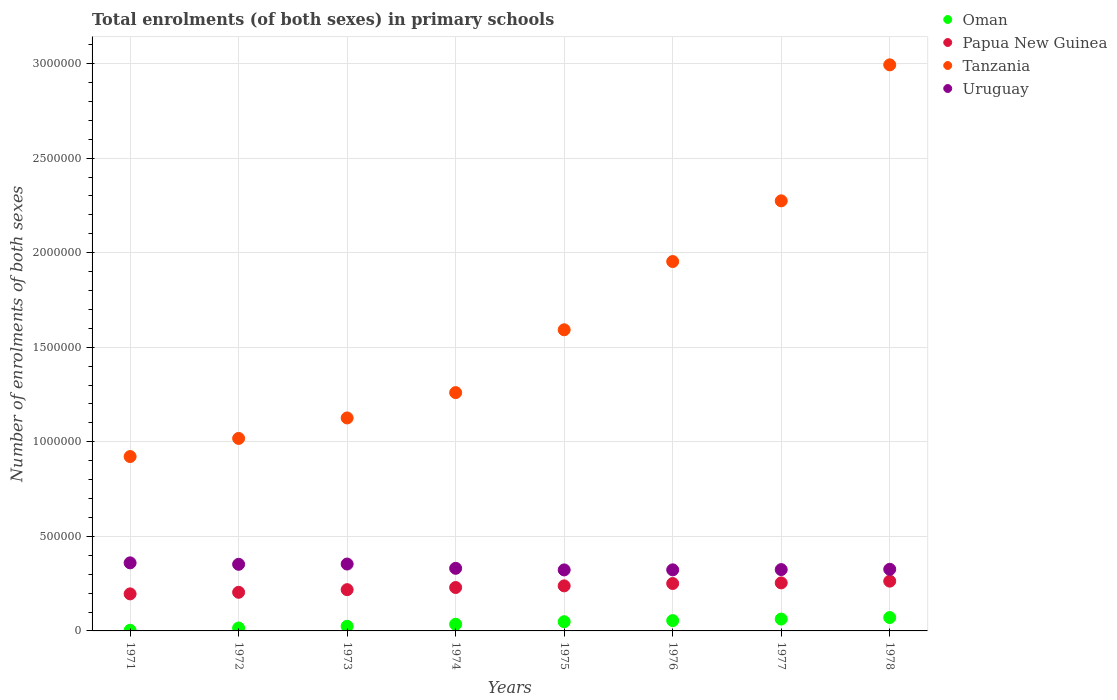Is the number of dotlines equal to the number of legend labels?
Provide a succinct answer. Yes. What is the number of enrolments in primary schools in Papua New Guinea in 1977?
Provide a succinct answer. 2.54e+05. Across all years, what is the maximum number of enrolments in primary schools in Tanzania?
Give a very brief answer. 2.99e+06. Across all years, what is the minimum number of enrolments in primary schools in Papua New Guinea?
Your answer should be very brief. 1.96e+05. In which year was the number of enrolments in primary schools in Uruguay maximum?
Make the answer very short. 1971. What is the total number of enrolments in primary schools in Uruguay in the graph?
Your response must be concise. 2.69e+06. What is the difference between the number of enrolments in primary schools in Tanzania in 1973 and that in 1974?
Provide a short and direct response. -1.34e+05. What is the difference between the number of enrolments in primary schools in Uruguay in 1978 and the number of enrolments in primary schools in Papua New Guinea in 1974?
Provide a short and direct response. 9.64e+04. What is the average number of enrolments in primary schools in Uruguay per year?
Offer a terse response. 3.37e+05. In the year 1977, what is the difference between the number of enrolments in primary schools in Oman and number of enrolments in primary schools in Uruguay?
Offer a very short reply. -2.62e+05. In how many years, is the number of enrolments in primary schools in Uruguay greater than 900000?
Give a very brief answer. 0. What is the ratio of the number of enrolments in primary schools in Papua New Guinea in 1971 to that in 1976?
Provide a short and direct response. 0.78. Is the number of enrolments in primary schools in Tanzania in 1972 less than that in 1974?
Make the answer very short. Yes. Is the difference between the number of enrolments in primary schools in Oman in 1976 and 1978 greater than the difference between the number of enrolments in primary schools in Uruguay in 1976 and 1978?
Offer a very short reply. No. What is the difference between the highest and the second highest number of enrolments in primary schools in Uruguay?
Provide a short and direct response. 6275. What is the difference between the highest and the lowest number of enrolments in primary schools in Oman?
Keep it short and to the point. 6.73e+04. Is the sum of the number of enrolments in primary schools in Uruguay in 1976 and 1978 greater than the maximum number of enrolments in primary schools in Oman across all years?
Your answer should be compact. Yes. Is it the case that in every year, the sum of the number of enrolments in primary schools in Uruguay and number of enrolments in primary schools in Papua New Guinea  is greater than the sum of number of enrolments in primary schools in Oman and number of enrolments in primary schools in Tanzania?
Offer a terse response. No. Is it the case that in every year, the sum of the number of enrolments in primary schools in Tanzania and number of enrolments in primary schools in Papua New Guinea  is greater than the number of enrolments in primary schools in Uruguay?
Give a very brief answer. Yes. Does the number of enrolments in primary schools in Papua New Guinea monotonically increase over the years?
Your response must be concise. Yes. Is the number of enrolments in primary schools in Uruguay strictly less than the number of enrolments in primary schools in Oman over the years?
Give a very brief answer. No. How many dotlines are there?
Ensure brevity in your answer.  4. Does the graph contain grids?
Give a very brief answer. Yes. Where does the legend appear in the graph?
Your answer should be compact. Top right. How many legend labels are there?
Ensure brevity in your answer.  4. How are the legend labels stacked?
Your answer should be compact. Vertical. What is the title of the graph?
Keep it short and to the point. Total enrolments (of both sexes) in primary schools. Does "Bhutan" appear as one of the legend labels in the graph?
Provide a succinct answer. No. What is the label or title of the X-axis?
Give a very brief answer. Years. What is the label or title of the Y-axis?
Your response must be concise. Number of enrolments of both sexes. What is the Number of enrolments of both sexes of Oman in 1971?
Keep it short and to the point. 3478. What is the Number of enrolments of both sexes of Papua New Guinea in 1971?
Offer a very short reply. 1.96e+05. What is the Number of enrolments of both sexes of Tanzania in 1971?
Your response must be concise. 9.22e+05. What is the Number of enrolments of both sexes of Uruguay in 1971?
Your answer should be compact. 3.60e+05. What is the Number of enrolments of both sexes in Oman in 1972?
Make the answer very short. 1.53e+04. What is the Number of enrolments of both sexes of Papua New Guinea in 1972?
Give a very brief answer. 2.04e+05. What is the Number of enrolments of both sexes of Tanzania in 1972?
Your response must be concise. 1.02e+06. What is the Number of enrolments of both sexes in Uruguay in 1972?
Ensure brevity in your answer.  3.52e+05. What is the Number of enrolments of both sexes of Oman in 1973?
Offer a terse response. 2.44e+04. What is the Number of enrolments of both sexes of Papua New Guinea in 1973?
Your answer should be very brief. 2.18e+05. What is the Number of enrolments of both sexes in Tanzania in 1973?
Your response must be concise. 1.13e+06. What is the Number of enrolments of both sexes in Uruguay in 1973?
Offer a terse response. 3.54e+05. What is the Number of enrolments of both sexes of Oman in 1974?
Offer a terse response. 3.53e+04. What is the Number of enrolments of both sexes of Papua New Guinea in 1974?
Your answer should be very brief. 2.30e+05. What is the Number of enrolments of both sexes in Tanzania in 1974?
Provide a succinct answer. 1.26e+06. What is the Number of enrolments of both sexes of Uruguay in 1974?
Your answer should be compact. 3.31e+05. What is the Number of enrolments of both sexes in Oman in 1975?
Ensure brevity in your answer.  4.86e+04. What is the Number of enrolments of both sexes in Papua New Guinea in 1975?
Provide a short and direct response. 2.38e+05. What is the Number of enrolments of both sexes in Tanzania in 1975?
Provide a short and direct response. 1.59e+06. What is the Number of enrolments of both sexes in Uruguay in 1975?
Provide a short and direct response. 3.23e+05. What is the Number of enrolments of both sexes of Oman in 1976?
Offer a very short reply. 5.46e+04. What is the Number of enrolments of both sexes of Papua New Guinea in 1976?
Your answer should be compact. 2.51e+05. What is the Number of enrolments of both sexes of Tanzania in 1976?
Your answer should be very brief. 1.95e+06. What is the Number of enrolments of both sexes of Uruguay in 1976?
Make the answer very short. 3.23e+05. What is the Number of enrolments of both sexes in Oman in 1977?
Keep it short and to the point. 6.26e+04. What is the Number of enrolments of both sexes in Papua New Guinea in 1977?
Your answer should be compact. 2.54e+05. What is the Number of enrolments of both sexes in Tanzania in 1977?
Ensure brevity in your answer.  2.27e+06. What is the Number of enrolments of both sexes in Uruguay in 1977?
Your response must be concise. 3.24e+05. What is the Number of enrolments of both sexes of Oman in 1978?
Ensure brevity in your answer.  7.08e+04. What is the Number of enrolments of both sexes in Papua New Guinea in 1978?
Offer a very short reply. 2.63e+05. What is the Number of enrolments of both sexes in Tanzania in 1978?
Provide a short and direct response. 2.99e+06. What is the Number of enrolments of both sexes of Uruguay in 1978?
Provide a succinct answer. 3.26e+05. Across all years, what is the maximum Number of enrolments of both sexes in Oman?
Keep it short and to the point. 7.08e+04. Across all years, what is the maximum Number of enrolments of both sexes of Papua New Guinea?
Your response must be concise. 2.63e+05. Across all years, what is the maximum Number of enrolments of both sexes of Tanzania?
Offer a terse response. 2.99e+06. Across all years, what is the maximum Number of enrolments of both sexes of Uruguay?
Keep it short and to the point. 3.60e+05. Across all years, what is the minimum Number of enrolments of both sexes in Oman?
Give a very brief answer. 3478. Across all years, what is the minimum Number of enrolments of both sexes in Papua New Guinea?
Provide a succinct answer. 1.96e+05. Across all years, what is the minimum Number of enrolments of both sexes in Tanzania?
Ensure brevity in your answer.  9.22e+05. Across all years, what is the minimum Number of enrolments of both sexes in Uruguay?
Keep it short and to the point. 3.23e+05. What is the total Number of enrolments of both sexes of Oman in the graph?
Provide a succinct answer. 3.15e+05. What is the total Number of enrolments of both sexes of Papua New Guinea in the graph?
Your answer should be compact. 1.85e+06. What is the total Number of enrolments of both sexes of Tanzania in the graph?
Your response must be concise. 1.31e+07. What is the total Number of enrolments of both sexes of Uruguay in the graph?
Offer a terse response. 2.69e+06. What is the difference between the Number of enrolments of both sexes in Oman in 1971 and that in 1972?
Offer a terse response. -1.19e+04. What is the difference between the Number of enrolments of both sexes in Papua New Guinea in 1971 and that in 1972?
Provide a succinct answer. -8359. What is the difference between the Number of enrolments of both sexes in Tanzania in 1971 and that in 1972?
Your response must be concise. -9.59e+04. What is the difference between the Number of enrolments of both sexes in Uruguay in 1971 and that in 1972?
Offer a terse response. 7719. What is the difference between the Number of enrolments of both sexes of Oman in 1971 and that in 1973?
Offer a terse response. -2.09e+04. What is the difference between the Number of enrolments of both sexes of Papua New Guinea in 1971 and that in 1973?
Offer a terse response. -2.23e+04. What is the difference between the Number of enrolments of both sexes in Tanzania in 1971 and that in 1973?
Your response must be concise. -2.04e+05. What is the difference between the Number of enrolments of both sexes in Uruguay in 1971 and that in 1973?
Your response must be concise. 6275. What is the difference between the Number of enrolments of both sexes in Oman in 1971 and that in 1974?
Your answer should be very brief. -3.18e+04. What is the difference between the Number of enrolments of both sexes of Papua New Guinea in 1971 and that in 1974?
Ensure brevity in your answer.  -3.37e+04. What is the difference between the Number of enrolments of both sexes of Tanzania in 1971 and that in 1974?
Your answer should be compact. -3.38e+05. What is the difference between the Number of enrolments of both sexes in Uruguay in 1971 and that in 1974?
Your answer should be very brief. 2.89e+04. What is the difference between the Number of enrolments of both sexes in Oman in 1971 and that in 1975?
Offer a terse response. -4.52e+04. What is the difference between the Number of enrolments of both sexes in Papua New Guinea in 1971 and that in 1975?
Your answer should be very brief. -4.24e+04. What is the difference between the Number of enrolments of both sexes in Tanzania in 1971 and that in 1975?
Provide a short and direct response. -6.70e+05. What is the difference between the Number of enrolments of both sexes of Uruguay in 1971 and that in 1975?
Provide a short and direct response. 3.73e+04. What is the difference between the Number of enrolments of both sexes in Oman in 1971 and that in 1976?
Your answer should be very brief. -5.11e+04. What is the difference between the Number of enrolments of both sexes of Papua New Guinea in 1971 and that in 1976?
Ensure brevity in your answer.  -5.49e+04. What is the difference between the Number of enrolments of both sexes in Tanzania in 1971 and that in 1976?
Provide a short and direct response. -1.03e+06. What is the difference between the Number of enrolments of both sexes in Uruguay in 1971 and that in 1976?
Offer a very short reply. 3.70e+04. What is the difference between the Number of enrolments of both sexes of Oman in 1971 and that in 1977?
Offer a very short reply. -5.92e+04. What is the difference between the Number of enrolments of both sexes in Papua New Guinea in 1971 and that in 1977?
Give a very brief answer. -5.81e+04. What is the difference between the Number of enrolments of both sexes of Tanzania in 1971 and that in 1977?
Ensure brevity in your answer.  -1.35e+06. What is the difference between the Number of enrolments of both sexes of Uruguay in 1971 and that in 1977?
Your response must be concise. 3.56e+04. What is the difference between the Number of enrolments of both sexes of Oman in 1971 and that in 1978?
Give a very brief answer. -6.73e+04. What is the difference between the Number of enrolments of both sexes of Papua New Guinea in 1971 and that in 1978?
Provide a succinct answer. -6.73e+04. What is the difference between the Number of enrolments of both sexes of Tanzania in 1971 and that in 1978?
Ensure brevity in your answer.  -2.07e+06. What is the difference between the Number of enrolments of both sexes in Uruguay in 1971 and that in 1978?
Provide a succinct answer. 3.40e+04. What is the difference between the Number of enrolments of both sexes in Oman in 1972 and that in 1973?
Your answer should be compact. -9079. What is the difference between the Number of enrolments of both sexes of Papua New Guinea in 1972 and that in 1973?
Provide a succinct answer. -1.39e+04. What is the difference between the Number of enrolments of both sexes in Tanzania in 1972 and that in 1973?
Ensure brevity in your answer.  -1.08e+05. What is the difference between the Number of enrolments of both sexes of Uruguay in 1972 and that in 1973?
Provide a succinct answer. -1444. What is the difference between the Number of enrolments of both sexes of Oman in 1972 and that in 1974?
Offer a terse response. -2.00e+04. What is the difference between the Number of enrolments of both sexes in Papua New Guinea in 1972 and that in 1974?
Offer a very short reply. -2.53e+04. What is the difference between the Number of enrolments of both sexes in Tanzania in 1972 and that in 1974?
Ensure brevity in your answer.  -2.42e+05. What is the difference between the Number of enrolments of both sexes of Uruguay in 1972 and that in 1974?
Provide a succinct answer. 2.12e+04. What is the difference between the Number of enrolments of both sexes in Oman in 1972 and that in 1975?
Ensure brevity in your answer.  -3.33e+04. What is the difference between the Number of enrolments of both sexes of Papua New Guinea in 1972 and that in 1975?
Make the answer very short. -3.40e+04. What is the difference between the Number of enrolments of both sexes of Tanzania in 1972 and that in 1975?
Ensure brevity in your answer.  -5.74e+05. What is the difference between the Number of enrolments of both sexes of Uruguay in 1972 and that in 1975?
Keep it short and to the point. 2.96e+04. What is the difference between the Number of enrolments of both sexes of Oman in 1972 and that in 1976?
Your response must be concise. -3.93e+04. What is the difference between the Number of enrolments of both sexes in Papua New Guinea in 1972 and that in 1976?
Give a very brief answer. -4.65e+04. What is the difference between the Number of enrolments of both sexes of Tanzania in 1972 and that in 1976?
Give a very brief answer. -9.35e+05. What is the difference between the Number of enrolments of both sexes of Uruguay in 1972 and that in 1976?
Your answer should be compact. 2.93e+04. What is the difference between the Number of enrolments of both sexes in Oman in 1972 and that in 1977?
Ensure brevity in your answer.  -4.73e+04. What is the difference between the Number of enrolments of both sexes of Papua New Guinea in 1972 and that in 1977?
Keep it short and to the point. -4.98e+04. What is the difference between the Number of enrolments of both sexes of Tanzania in 1972 and that in 1977?
Keep it short and to the point. -1.26e+06. What is the difference between the Number of enrolments of both sexes in Uruguay in 1972 and that in 1977?
Provide a succinct answer. 2.78e+04. What is the difference between the Number of enrolments of both sexes of Oman in 1972 and that in 1978?
Your response must be concise. -5.54e+04. What is the difference between the Number of enrolments of both sexes in Papua New Guinea in 1972 and that in 1978?
Make the answer very short. -5.90e+04. What is the difference between the Number of enrolments of both sexes in Tanzania in 1972 and that in 1978?
Keep it short and to the point. -1.98e+06. What is the difference between the Number of enrolments of both sexes of Uruguay in 1972 and that in 1978?
Ensure brevity in your answer.  2.63e+04. What is the difference between the Number of enrolments of both sexes of Oman in 1973 and that in 1974?
Make the answer very short. -1.09e+04. What is the difference between the Number of enrolments of both sexes in Papua New Guinea in 1973 and that in 1974?
Provide a short and direct response. -1.14e+04. What is the difference between the Number of enrolments of both sexes in Tanzania in 1973 and that in 1974?
Provide a short and direct response. -1.34e+05. What is the difference between the Number of enrolments of both sexes of Uruguay in 1973 and that in 1974?
Provide a succinct answer. 2.26e+04. What is the difference between the Number of enrolments of both sexes of Oman in 1973 and that in 1975?
Provide a succinct answer. -2.42e+04. What is the difference between the Number of enrolments of both sexes in Papua New Guinea in 1973 and that in 1975?
Your answer should be very brief. -2.01e+04. What is the difference between the Number of enrolments of both sexes of Tanzania in 1973 and that in 1975?
Keep it short and to the point. -4.66e+05. What is the difference between the Number of enrolments of both sexes of Uruguay in 1973 and that in 1975?
Offer a very short reply. 3.11e+04. What is the difference between the Number of enrolments of both sexes in Oman in 1973 and that in 1976?
Ensure brevity in your answer.  -3.02e+04. What is the difference between the Number of enrolments of both sexes in Papua New Guinea in 1973 and that in 1976?
Ensure brevity in your answer.  -3.25e+04. What is the difference between the Number of enrolments of both sexes in Tanzania in 1973 and that in 1976?
Your response must be concise. -8.27e+05. What is the difference between the Number of enrolments of both sexes in Uruguay in 1973 and that in 1976?
Keep it short and to the point. 3.07e+04. What is the difference between the Number of enrolments of both sexes in Oman in 1973 and that in 1977?
Make the answer very short. -3.82e+04. What is the difference between the Number of enrolments of both sexes in Papua New Guinea in 1973 and that in 1977?
Provide a succinct answer. -3.58e+04. What is the difference between the Number of enrolments of both sexes in Tanzania in 1973 and that in 1977?
Give a very brief answer. -1.15e+06. What is the difference between the Number of enrolments of both sexes of Uruguay in 1973 and that in 1977?
Ensure brevity in your answer.  2.93e+04. What is the difference between the Number of enrolments of both sexes of Oman in 1973 and that in 1978?
Provide a short and direct response. -4.63e+04. What is the difference between the Number of enrolments of both sexes of Papua New Guinea in 1973 and that in 1978?
Offer a very short reply. -4.50e+04. What is the difference between the Number of enrolments of both sexes of Tanzania in 1973 and that in 1978?
Offer a terse response. -1.87e+06. What is the difference between the Number of enrolments of both sexes in Uruguay in 1973 and that in 1978?
Give a very brief answer. 2.78e+04. What is the difference between the Number of enrolments of both sexes of Oman in 1974 and that in 1975?
Your answer should be compact. -1.34e+04. What is the difference between the Number of enrolments of both sexes of Papua New Guinea in 1974 and that in 1975?
Your answer should be very brief. -8740. What is the difference between the Number of enrolments of both sexes in Tanzania in 1974 and that in 1975?
Give a very brief answer. -3.32e+05. What is the difference between the Number of enrolments of both sexes in Uruguay in 1974 and that in 1975?
Your response must be concise. 8445. What is the difference between the Number of enrolments of both sexes of Oman in 1974 and that in 1976?
Provide a short and direct response. -1.93e+04. What is the difference between the Number of enrolments of both sexes in Papua New Guinea in 1974 and that in 1976?
Make the answer very short. -2.12e+04. What is the difference between the Number of enrolments of both sexes of Tanzania in 1974 and that in 1976?
Keep it short and to the point. -6.93e+05. What is the difference between the Number of enrolments of both sexes in Uruguay in 1974 and that in 1976?
Ensure brevity in your answer.  8105. What is the difference between the Number of enrolments of both sexes in Oman in 1974 and that in 1977?
Your response must be concise. -2.73e+04. What is the difference between the Number of enrolments of both sexes in Papua New Guinea in 1974 and that in 1977?
Offer a very short reply. -2.45e+04. What is the difference between the Number of enrolments of both sexes of Tanzania in 1974 and that in 1977?
Your answer should be very brief. -1.01e+06. What is the difference between the Number of enrolments of both sexes of Uruguay in 1974 and that in 1977?
Ensure brevity in your answer.  6686. What is the difference between the Number of enrolments of both sexes in Oman in 1974 and that in 1978?
Provide a succinct answer. -3.55e+04. What is the difference between the Number of enrolments of both sexes of Papua New Guinea in 1974 and that in 1978?
Your answer should be very brief. -3.36e+04. What is the difference between the Number of enrolments of both sexes in Tanzania in 1974 and that in 1978?
Provide a succinct answer. -1.73e+06. What is the difference between the Number of enrolments of both sexes in Uruguay in 1974 and that in 1978?
Ensure brevity in your answer.  5159. What is the difference between the Number of enrolments of both sexes in Oman in 1975 and that in 1976?
Give a very brief answer. -5962. What is the difference between the Number of enrolments of both sexes in Papua New Guinea in 1975 and that in 1976?
Make the answer very short. -1.24e+04. What is the difference between the Number of enrolments of both sexes of Tanzania in 1975 and that in 1976?
Your response must be concise. -3.61e+05. What is the difference between the Number of enrolments of both sexes of Uruguay in 1975 and that in 1976?
Ensure brevity in your answer.  -340. What is the difference between the Number of enrolments of both sexes of Oman in 1975 and that in 1977?
Your response must be concise. -1.40e+04. What is the difference between the Number of enrolments of both sexes of Papua New Guinea in 1975 and that in 1977?
Your answer should be compact. -1.57e+04. What is the difference between the Number of enrolments of both sexes of Tanzania in 1975 and that in 1977?
Keep it short and to the point. -6.82e+05. What is the difference between the Number of enrolments of both sexes of Uruguay in 1975 and that in 1977?
Keep it short and to the point. -1759. What is the difference between the Number of enrolments of both sexes in Oman in 1975 and that in 1978?
Provide a succinct answer. -2.21e+04. What is the difference between the Number of enrolments of both sexes of Papua New Guinea in 1975 and that in 1978?
Offer a terse response. -2.49e+04. What is the difference between the Number of enrolments of both sexes in Tanzania in 1975 and that in 1978?
Your answer should be very brief. -1.40e+06. What is the difference between the Number of enrolments of both sexes of Uruguay in 1975 and that in 1978?
Your answer should be compact. -3286. What is the difference between the Number of enrolments of both sexes in Oman in 1976 and that in 1977?
Ensure brevity in your answer.  -8019. What is the difference between the Number of enrolments of both sexes of Papua New Guinea in 1976 and that in 1977?
Your response must be concise. -3272. What is the difference between the Number of enrolments of both sexes in Tanzania in 1976 and that in 1977?
Keep it short and to the point. -3.21e+05. What is the difference between the Number of enrolments of both sexes of Uruguay in 1976 and that in 1977?
Make the answer very short. -1419. What is the difference between the Number of enrolments of both sexes of Oman in 1976 and that in 1978?
Provide a short and direct response. -1.61e+04. What is the difference between the Number of enrolments of both sexes in Papua New Guinea in 1976 and that in 1978?
Your answer should be compact. -1.25e+04. What is the difference between the Number of enrolments of both sexes in Tanzania in 1976 and that in 1978?
Offer a very short reply. -1.04e+06. What is the difference between the Number of enrolments of both sexes in Uruguay in 1976 and that in 1978?
Your answer should be compact. -2946. What is the difference between the Number of enrolments of both sexes of Oman in 1977 and that in 1978?
Provide a succinct answer. -8121. What is the difference between the Number of enrolments of both sexes of Papua New Guinea in 1977 and that in 1978?
Offer a very short reply. -9184. What is the difference between the Number of enrolments of both sexes of Tanzania in 1977 and that in 1978?
Make the answer very short. -7.19e+05. What is the difference between the Number of enrolments of both sexes in Uruguay in 1977 and that in 1978?
Your response must be concise. -1527. What is the difference between the Number of enrolments of both sexes of Oman in 1971 and the Number of enrolments of both sexes of Papua New Guinea in 1972?
Offer a terse response. -2.01e+05. What is the difference between the Number of enrolments of both sexes of Oman in 1971 and the Number of enrolments of both sexes of Tanzania in 1972?
Your response must be concise. -1.01e+06. What is the difference between the Number of enrolments of both sexes of Oman in 1971 and the Number of enrolments of both sexes of Uruguay in 1972?
Make the answer very short. -3.49e+05. What is the difference between the Number of enrolments of both sexes of Papua New Guinea in 1971 and the Number of enrolments of both sexes of Tanzania in 1972?
Provide a short and direct response. -8.22e+05. What is the difference between the Number of enrolments of both sexes in Papua New Guinea in 1971 and the Number of enrolments of both sexes in Uruguay in 1972?
Provide a succinct answer. -1.56e+05. What is the difference between the Number of enrolments of both sexes of Tanzania in 1971 and the Number of enrolments of both sexes of Uruguay in 1972?
Keep it short and to the point. 5.70e+05. What is the difference between the Number of enrolments of both sexes in Oman in 1971 and the Number of enrolments of both sexes in Papua New Guinea in 1973?
Your answer should be compact. -2.15e+05. What is the difference between the Number of enrolments of both sexes of Oman in 1971 and the Number of enrolments of both sexes of Tanzania in 1973?
Offer a terse response. -1.12e+06. What is the difference between the Number of enrolments of both sexes of Oman in 1971 and the Number of enrolments of both sexes of Uruguay in 1973?
Offer a terse response. -3.50e+05. What is the difference between the Number of enrolments of both sexes of Papua New Guinea in 1971 and the Number of enrolments of both sexes of Tanzania in 1973?
Provide a short and direct response. -9.30e+05. What is the difference between the Number of enrolments of both sexes in Papua New Guinea in 1971 and the Number of enrolments of both sexes in Uruguay in 1973?
Make the answer very short. -1.58e+05. What is the difference between the Number of enrolments of both sexes of Tanzania in 1971 and the Number of enrolments of both sexes of Uruguay in 1973?
Give a very brief answer. 5.68e+05. What is the difference between the Number of enrolments of both sexes of Oman in 1971 and the Number of enrolments of both sexes of Papua New Guinea in 1974?
Make the answer very short. -2.26e+05. What is the difference between the Number of enrolments of both sexes of Oman in 1971 and the Number of enrolments of both sexes of Tanzania in 1974?
Provide a succinct answer. -1.26e+06. What is the difference between the Number of enrolments of both sexes in Oman in 1971 and the Number of enrolments of both sexes in Uruguay in 1974?
Provide a short and direct response. -3.28e+05. What is the difference between the Number of enrolments of both sexes of Papua New Guinea in 1971 and the Number of enrolments of both sexes of Tanzania in 1974?
Ensure brevity in your answer.  -1.06e+06. What is the difference between the Number of enrolments of both sexes in Papua New Guinea in 1971 and the Number of enrolments of both sexes in Uruguay in 1974?
Provide a succinct answer. -1.35e+05. What is the difference between the Number of enrolments of both sexes of Tanzania in 1971 and the Number of enrolments of both sexes of Uruguay in 1974?
Provide a short and direct response. 5.91e+05. What is the difference between the Number of enrolments of both sexes of Oman in 1971 and the Number of enrolments of both sexes of Papua New Guinea in 1975?
Provide a short and direct response. -2.35e+05. What is the difference between the Number of enrolments of both sexes in Oman in 1971 and the Number of enrolments of both sexes in Tanzania in 1975?
Ensure brevity in your answer.  -1.59e+06. What is the difference between the Number of enrolments of both sexes of Oman in 1971 and the Number of enrolments of both sexes of Uruguay in 1975?
Offer a terse response. -3.19e+05. What is the difference between the Number of enrolments of both sexes of Papua New Guinea in 1971 and the Number of enrolments of both sexes of Tanzania in 1975?
Your response must be concise. -1.40e+06. What is the difference between the Number of enrolments of both sexes of Papua New Guinea in 1971 and the Number of enrolments of both sexes of Uruguay in 1975?
Keep it short and to the point. -1.27e+05. What is the difference between the Number of enrolments of both sexes in Tanzania in 1971 and the Number of enrolments of both sexes in Uruguay in 1975?
Offer a terse response. 5.99e+05. What is the difference between the Number of enrolments of both sexes of Oman in 1971 and the Number of enrolments of both sexes of Papua New Guinea in 1976?
Your response must be concise. -2.47e+05. What is the difference between the Number of enrolments of both sexes of Oman in 1971 and the Number of enrolments of both sexes of Tanzania in 1976?
Provide a succinct answer. -1.95e+06. What is the difference between the Number of enrolments of both sexes in Oman in 1971 and the Number of enrolments of both sexes in Uruguay in 1976?
Your answer should be very brief. -3.19e+05. What is the difference between the Number of enrolments of both sexes of Papua New Guinea in 1971 and the Number of enrolments of both sexes of Tanzania in 1976?
Provide a short and direct response. -1.76e+06. What is the difference between the Number of enrolments of both sexes in Papua New Guinea in 1971 and the Number of enrolments of both sexes in Uruguay in 1976?
Provide a succinct answer. -1.27e+05. What is the difference between the Number of enrolments of both sexes in Tanzania in 1971 and the Number of enrolments of both sexes in Uruguay in 1976?
Your response must be concise. 5.99e+05. What is the difference between the Number of enrolments of both sexes of Oman in 1971 and the Number of enrolments of both sexes of Papua New Guinea in 1977?
Offer a very short reply. -2.51e+05. What is the difference between the Number of enrolments of both sexes of Oman in 1971 and the Number of enrolments of both sexes of Tanzania in 1977?
Offer a very short reply. -2.27e+06. What is the difference between the Number of enrolments of both sexes in Oman in 1971 and the Number of enrolments of both sexes in Uruguay in 1977?
Provide a succinct answer. -3.21e+05. What is the difference between the Number of enrolments of both sexes in Papua New Guinea in 1971 and the Number of enrolments of both sexes in Tanzania in 1977?
Provide a short and direct response. -2.08e+06. What is the difference between the Number of enrolments of both sexes in Papua New Guinea in 1971 and the Number of enrolments of both sexes in Uruguay in 1977?
Give a very brief answer. -1.29e+05. What is the difference between the Number of enrolments of both sexes in Tanzania in 1971 and the Number of enrolments of both sexes in Uruguay in 1977?
Provide a short and direct response. 5.98e+05. What is the difference between the Number of enrolments of both sexes of Oman in 1971 and the Number of enrolments of both sexes of Papua New Guinea in 1978?
Your response must be concise. -2.60e+05. What is the difference between the Number of enrolments of both sexes of Oman in 1971 and the Number of enrolments of both sexes of Tanzania in 1978?
Provide a short and direct response. -2.99e+06. What is the difference between the Number of enrolments of both sexes of Oman in 1971 and the Number of enrolments of both sexes of Uruguay in 1978?
Provide a short and direct response. -3.22e+05. What is the difference between the Number of enrolments of both sexes of Papua New Guinea in 1971 and the Number of enrolments of both sexes of Tanzania in 1978?
Make the answer very short. -2.80e+06. What is the difference between the Number of enrolments of both sexes in Papua New Guinea in 1971 and the Number of enrolments of both sexes in Uruguay in 1978?
Provide a short and direct response. -1.30e+05. What is the difference between the Number of enrolments of both sexes in Tanzania in 1971 and the Number of enrolments of both sexes in Uruguay in 1978?
Your answer should be very brief. 5.96e+05. What is the difference between the Number of enrolments of both sexes in Oman in 1972 and the Number of enrolments of both sexes in Papua New Guinea in 1973?
Your answer should be very brief. -2.03e+05. What is the difference between the Number of enrolments of both sexes in Oman in 1972 and the Number of enrolments of both sexes in Tanzania in 1973?
Provide a succinct answer. -1.11e+06. What is the difference between the Number of enrolments of both sexes of Oman in 1972 and the Number of enrolments of both sexes of Uruguay in 1973?
Your answer should be compact. -3.38e+05. What is the difference between the Number of enrolments of both sexes of Papua New Guinea in 1972 and the Number of enrolments of both sexes of Tanzania in 1973?
Ensure brevity in your answer.  -9.22e+05. What is the difference between the Number of enrolments of both sexes in Papua New Guinea in 1972 and the Number of enrolments of both sexes in Uruguay in 1973?
Ensure brevity in your answer.  -1.49e+05. What is the difference between the Number of enrolments of both sexes of Tanzania in 1972 and the Number of enrolments of both sexes of Uruguay in 1973?
Your response must be concise. 6.64e+05. What is the difference between the Number of enrolments of both sexes in Oman in 1972 and the Number of enrolments of both sexes in Papua New Guinea in 1974?
Offer a terse response. -2.14e+05. What is the difference between the Number of enrolments of both sexes of Oman in 1972 and the Number of enrolments of both sexes of Tanzania in 1974?
Your response must be concise. -1.24e+06. What is the difference between the Number of enrolments of both sexes in Oman in 1972 and the Number of enrolments of both sexes in Uruguay in 1974?
Offer a very short reply. -3.16e+05. What is the difference between the Number of enrolments of both sexes in Papua New Guinea in 1972 and the Number of enrolments of both sexes in Tanzania in 1974?
Offer a terse response. -1.06e+06. What is the difference between the Number of enrolments of both sexes in Papua New Guinea in 1972 and the Number of enrolments of both sexes in Uruguay in 1974?
Make the answer very short. -1.27e+05. What is the difference between the Number of enrolments of both sexes of Tanzania in 1972 and the Number of enrolments of both sexes of Uruguay in 1974?
Your answer should be compact. 6.87e+05. What is the difference between the Number of enrolments of both sexes of Oman in 1972 and the Number of enrolments of both sexes of Papua New Guinea in 1975?
Offer a terse response. -2.23e+05. What is the difference between the Number of enrolments of both sexes of Oman in 1972 and the Number of enrolments of both sexes of Tanzania in 1975?
Keep it short and to the point. -1.58e+06. What is the difference between the Number of enrolments of both sexes in Oman in 1972 and the Number of enrolments of both sexes in Uruguay in 1975?
Make the answer very short. -3.07e+05. What is the difference between the Number of enrolments of both sexes in Papua New Guinea in 1972 and the Number of enrolments of both sexes in Tanzania in 1975?
Offer a terse response. -1.39e+06. What is the difference between the Number of enrolments of both sexes of Papua New Guinea in 1972 and the Number of enrolments of both sexes of Uruguay in 1975?
Keep it short and to the point. -1.18e+05. What is the difference between the Number of enrolments of both sexes of Tanzania in 1972 and the Number of enrolments of both sexes of Uruguay in 1975?
Provide a succinct answer. 6.95e+05. What is the difference between the Number of enrolments of both sexes of Oman in 1972 and the Number of enrolments of both sexes of Papua New Guinea in 1976?
Your response must be concise. -2.35e+05. What is the difference between the Number of enrolments of both sexes in Oman in 1972 and the Number of enrolments of both sexes in Tanzania in 1976?
Your answer should be very brief. -1.94e+06. What is the difference between the Number of enrolments of both sexes of Oman in 1972 and the Number of enrolments of both sexes of Uruguay in 1976?
Offer a very short reply. -3.08e+05. What is the difference between the Number of enrolments of both sexes of Papua New Guinea in 1972 and the Number of enrolments of both sexes of Tanzania in 1976?
Keep it short and to the point. -1.75e+06. What is the difference between the Number of enrolments of both sexes of Papua New Guinea in 1972 and the Number of enrolments of both sexes of Uruguay in 1976?
Give a very brief answer. -1.19e+05. What is the difference between the Number of enrolments of both sexes in Tanzania in 1972 and the Number of enrolments of both sexes in Uruguay in 1976?
Provide a short and direct response. 6.95e+05. What is the difference between the Number of enrolments of both sexes of Oman in 1972 and the Number of enrolments of both sexes of Papua New Guinea in 1977?
Make the answer very short. -2.39e+05. What is the difference between the Number of enrolments of both sexes of Oman in 1972 and the Number of enrolments of both sexes of Tanzania in 1977?
Provide a short and direct response. -2.26e+06. What is the difference between the Number of enrolments of both sexes in Oman in 1972 and the Number of enrolments of both sexes in Uruguay in 1977?
Your answer should be compact. -3.09e+05. What is the difference between the Number of enrolments of both sexes in Papua New Guinea in 1972 and the Number of enrolments of both sexes in Tanzania in 1977?
Your answer should be very brief. -2.07e+06. What is the difference between the Number of enrolments of both sexes of Papua New Guinea in 1972 and the Number of enrolments of both sexes of Uruguay in 1977?
Keep it short and to the point. -1.20e+05. What is the difference between the Number of enrolments of both sexes in Tanzania in 1972 and the Number of enrolments of both sexes in Uruguay in 1977?
Your answer should be compact. 6.94e+05. What is the difference between the Number of enrolments of both sexes in Oman in 1972 and the Number of enrolments of both sexes in Papua New Guinea in 1978?
Offer a very short reply. -2.48e+05. What is the difference between the Number of enrolments of both sexes of Oman in 1972 and the Number of enrolments of both sexes of Tanzania in 1978?
Offer a very short reply. -2.98e+06. What is the difference between the Number of enrolments of both sexes in Oman in 1972 and the Number of enrolments of both sexes in Uruguay in 1978?
Keep it short and to the point. -3.11e+05. What is the difference between the Number of enrolments of both sexes of Papua New Guinea in 1972 and the Number of enrolments of both sexes of Tanzania in 1978?
Provide a succinct answer. -2.79e+06. What is the difference between the Number of enrolments of both sexes in Papua New Guinea in 1972 and the Number of enrolments of both sexes in Uruguay in 1978?
Offer a terse response. -1.22e+05. What is the difference between the Number of enrolments of both sexes in Tanzania in 1972 and the Number of enrolments of both sexes in Uruguay in 1978?
Your answer should be compact. 6.92e+05. What is the difference between the Number of enrolments of both sexes in Oman in 1973 and the Number of enrolments of both sexes in Papua New Guinea in 1974?
Offer a terse response. -2.05e+05. What is the difference between the Number of enrolments of both sexes in Oman in 1973 and the Number of enrolments of both sexes in Tanzania in 1974?
Ensure brevity in your answer.  -1.24e+06. What is the difference between the Number of enrolments of both sexes of Oman in 1973 and the Number of enrolments of both sexes of Uruguay in 1974?
Make the answer very short. -3.07e+05. What is the difference between the Number of enrolments of both sexes in Papua New Guinea in 1973 and the Number of enrolments of both sexes in Tanzania in 1974?
Offer a terse response. -1.04e+06. What is the difference between the Number of enrolments of both sexes of Papua New Guinea in 1973 and the Number of enrolments of both sexes of Uruguay in 1974?
Give a very brief answer. -1.13e+05. What is the difference between the Number of enrolments of both sexes in Tanzania in 1973 and the Number of enrolments of both sexes in Uruguay in 1974?
Keep it short and to the point. 7.95e+05. What is the difference between the Number of enrolments of both sexes in Oman in 1973 and the Number of enrolments of both sexes in Papua New Guinea in 1975?
Provide a succinct answer. -2.14e+05. What is the difference between the Number of enrolments of both sexes of Oman in 1973 and the Number of enrolments of both sexes of Tanzania in 1975?
Offer a terse response. -1.57e+06. What is the difference between the Number of enrolments of both sexes of Oman in 1973 and the Number of enrolments of both sexes of Uruguay in 1975?
Your response must be concise. -2.98e+05. What is the difference between the Number of enrolments of both sexes of Papua New Guinea in 1973 and the Number of enrolments of both sexes of Tanzania in 1975?
Your response must be concise. -1.37e+06. What is the difference between the Number of enrolments of both sexes of Papua New Guinea in 1973 and the Number of enrolments of both sexes of Uruguay in 1975?
Keep it short and to the point. -1.04e+05. What is the difference between the Number of enrolments of both sexes of Tanzania in 1973 and the Number of enrolments of both sexes of Uruguay in 1975?
Provide a short and direct response. 8.04e+05. What is the difference between the Number of enrolments of both sexes in Oman in 1973 and the Number of enrolments of both sexes in Papua New Guinea in 1976?
Give a very brief answer. -2.26e+05. What is the difference between the Number of enrolments of both sexes of Oman in 1973 and the Number of enrolments of both sexes of Tanzania in 1976?
Provide a short and direct response. -1.93e+06. What is the difference between the Number of enrolments of both sexes in Oman in 1973 and the Number of enrolments of both sexes in Uruguay in 1976?
Provide a short and direct response. -2.99e+05. What is the difference between the Number of enrolments of both sexes in Papua New Guinea in 1973 and the Number of enrolments of both sexes in Tanzania in 1976?
Offer a terse response. -1.74e+06. What is the difference between the Number of enrolments of both sexes of Papua New Guinea in 1973 and the Number of enrolments of both sexes of Uruguay in 1976?
Keep it short and to the point. -1.05e+05. What is the difference between the Number of enrolments of both sexes of Tanzania in 1973 and the Number of enrolments of both sexes of Uruguay in 1976?
Provide a succinct answer. 8.03e+05. What is the difference between the Number of enrolments of both sexes in Oman in 1973 and the Number of enrolments of both sexes in Papua New Guinea in 1977?
Give a very brief answer. -2.30e+05. What is the difference between the Number of enrolments of both sexes of Oman in 1973 and the Number of enrolments of both sexes of Tanzania in 1977?
Ensure brevity in your answer.  -2.25e+06. What is the difference between the Number of enrolments of both sexes in Oman in 1973 and the Number of enrolments of both sexes in Uruguay in 1977?
Provide a succinct answer. -3.00e+05. What is the difference between the Number of enrolments of both sexes of Papua New Guinea in 1973 and the Number of enrolments of both sexes of Tanzania in 1977?
Ensure brevity in your answer.  -2.06e+06. What is the difference between the Number of enrolments of both sexes in Papua New Guinea in 1973 and the Number of enrolments of both sexes in Uruguay in 1977?
Keep it short and to the point. -1.06e+05. What is the difference between the Number of enrolments of both sexes of Tanzania in 1973 and the Number of enrolments of both sexes of Uruguay in 1977?
Offer a very short reply. 8.02e+05. What is the difference between the Number of enrolments of both sexes of Oman in 1973 and the Number of enrolments of both sexes of Papua New Guinea in 1978?
Make the answer very short. -2.39e+05. What is the difference between the Number of enrolments of both sexes in Oman in 1973 and the Number of enrolments of both sexes in Tanzania in 1978?
Offer a very short reply. -2.97e+06. What is the difference between the Number of enrolments of both sexes of Oman in 1973 and the Number of enrolments of both sexes of Uruguay in 1978?
Keep it short and to the point. -3.01e+05. What is the difference between the Number of enrolments of both sexes of Papua New Guinea in 1973 and the Number of enrolments of both sexes of Tanzania in 1978?
Make the answer very short. -2.78e+06. What is the difference between the Number of enrolments of both sexes in Papua New Guinea in 1973 and the Number of enrolments of both sexes in Uruguay in 1978?
Make the answer very short. -1.08e+05. What is the difference between the Number of enrolments of both sexes in Tanzania in 1973 and the Number of enrolments of both sexes in Uruguay in 1978?
Provide a succinct answer. 8.00e+05. What is the difference between the Number of enrolments of both sexes in Oman in 1974 and the Number of enrolments of both sexes in Papua New Guinea in 1975?
Keep it short and to the point. -2.03e+05. What is the difference between the Number of enrolments of both sexes of Oman in 1974 and the Number of enrolments of both sexes of Tanzania in 1975?
Your answer should be compact. -1.56e+06. What is the difference between the Number of enrolments of both sexes of Oman in 1974 and the Number of enrolments of both sexes of Uruguay in 1975?
Your answer should be compact. -2.87e+05. What is the difference between the Number of enrolments of both sexes in Papua New Guinea in 1974 and the Number of enrolments of both sexes in Tanzania in 1975?
Your response must be concise. -1.36e+06. What is the difference between the Number of enrolments of both sexes of Papua New Guinea in 1974 and the Number of enrolments of both sexes of Uruguay in 1975?
Your answer should be compact. -9.31e+04. What is the difference between the Number of enrolments of both sexes of Tanzania in 1974 and the Number of enrolments of both sexes of Uruguay in 1975?
Ensure brevity in your answer.  9.38e+05. What is the difference between the Number of enrolments of both sexes of Oman in 1974 and the Number of enrolments of both sexes of Papua New Guinea in 1976?
Offer a very short reply. -2.15e+05. What is the difference between the Number of enrolments of both sexes in Oman in 1974 and the Number of enrolments of both sexes in Tanzania in 1976?
Ensure brevity in your answer.  -1.92e+06. What is the difference between the Number of enrolments of both sexes in Oman in 1974 and the Number of enrolments of both sexes in Uruguay in 1976?
Your answer should be very brief. -2.88e+05. What is the difference between the Number of enrolments of both sexes of Papua New Guinea in 1974 and the Number of enrolments of both sexes of Tanzania in 1976?
Offer a very short reply. -1.72e+06. What is the difference between the Number of enrolments of both sexes of Papua New Guinea in 1974 and the Number of enrolments of both sexes of Uruguay in 1976?
Provide a short and direct response. -9.34e+04. What is the difference between the Number of enrolments of both sexes of Tanzania in 1974 and the Number of enrolments of both sexes of Uruguay in 1976?
Ensure brevity in your answer.  9.37e+05. What is the difference between the Number of enrolments of both sexes in Oman in 1974 and the Number of enrolments of both sexes in Papua New Guinea in 1977?
Offer a very short reply. -2.19e+05. What is the difference between the Number of enrolments of both sexes in Oman in 1974 and the Number of enrolments of both sexes in Tanzania in 1977?
Your answer should be compact. -2.24e+06. What is the difference between the Number of enrolments of both sexes in Oman in 1974 and the Number of enrolments of both sexes in Uruguay in 1977?
Keep it short and to the point. -2.89e+05. What is the difference between the Number of enrolments of both sexes in Papua New Guinea in 1974 and the Number of enrolments of both sexes in Tanzania in 1977?
Your answer should be compact. -2.04e+06. What is the difference between the Number of enrolments of both sexes of Papua New Guinea in 1974 and the Number of enrolments of both sexes of Uruguay in 1977?
Provide a short and direct response. -9.48e+04. What is the difference between the Number of enrolments of both sexes in Tanzania in 1974 and the Number of enrolments of both sexes in Uruguay in 1977?
Keep it short and to the point. 9.36e+05. What is the difference between the Number of enrolments of both sexes of Oman in 1974 and the Number of enrolments of both sexes of Papua New Guinea in 1978?
Your response must be concise. -2.28e+05. What is the difference between the Number of enrolments of both sexes of Oman in 1974 and the Number of enrolments of both sexes of Tanzania in 1978?
Keep it short and to the point. -2.96e+06. What is the difference between the Number of enrolments of both sexes of Oman in 1974 and the Number of enrolments of both sexes of Uruguay in 1978?
Ensure brevity in your answer.  -2.91e+05. What is the difference between the Number of enrolments of both sexes of Papua New Guinea in 1974 and the Number of enrolments of both sexes of Tanzania in 1978?
Your response must be concise. -2.76e+06. What is the difference between the Number of enrolments of both sexes of Papua New Guinea in 1974 and the Number of enrolments of both sexes of Uruguay in 1978?
Your answer should be compact. -9.64e+04. What is the difference between the Number of enrolments of both sexes of Tanzania in 1974 and the Number of enrolments of both sexes of Uruguay in 1978?
Your answer should be compact. 9.34e+05. What is the difference between the Number of enrolments of both sexes of Oman in 1975 and the Number of enrolments of both sexes of Papua New Guinea in 1976?
Make the answer very short. -2.02e+05. What is the difference between the Number of enrolments of both sexes of Oman in 1975 and the Number of enrolments of both sexes of Tanzania in 1976?
Your answer should be compact. -1.90e+06. What is the difference between the Number of enrolments of both sexes in Oman in 1975 and the Number of enrolments of both sexes in Uruguay in 1976?
Your response must be concise. -2.74e+05. What is the difference between the Number of enrolments of both sexes in Papua New Guinea in 1975 and the Number of enrolments of both sexes in Tanzania in 1976?
Your answer should be very brief. -1.72e+06. What is the difference between the Number of enrolments of both sexes of Papua New Guinea in 1975 and the Number of enrolments of both sexes of Uruguay in 1976?
Ensure brevity in your answer.  -8.47e+04. What is the difference between the Number of enrolments of both sexes in Tanzania in 1975 and the Number of enrolments of both sexes in Uruguay in 1976?
Provide a short and direct response. 1.27e+06. What is the difference between the Number of enrolments of both sexes of Oman in 1975 and the Number of enrolments of both sexes of Papua New Guinea in 1977?
Give a very brief answer. -2.05e+05. What is the difference between the Number of enrolments of both sexes of Oman in 1975 and the Number of enrolments of both sexes of Tanzania in 1977?
Keep it short and to the point. -2.23e+06. What is the difference between the Number of enrolments of both sexes in Oman in 1975 and the Number of enrolments of both sexes in Uruguay in 1977?
Ensure brevity in your answer.  -2.76e+05. What is the difference between the Number of enrolments of both sexes in Papua New Guinea in 1975 and the Number of enrolments of both sexes in Tanzania in 1977?
Offer a very short reply. -2.04e+06. What is the difference between the Number of enrolments of both sexes in Papua New Guinea in 1975 and the Number of enrolments of both sexes in Uruguay in 1977?
Offer a very short reply. -8.61e+04. What is the difference between the Number of enrolments of both sexes of Tanzania in 1975 and the Number of enrolments of both sexes of Uruguay in 1977?
Your answer should be compact. 1.27e+06. What is the difference between the Number of enrolments of both sexes in Oman in 1975 and the Number of enrolments of both sexes in Papua New Guinea in 1978?
Give a very brief answer. -2.15e+05. What is the difference between the Number of enrolments of both sexes in Oman in 1975 and the Number of enrolments of both sexes in Tanzania in 1978?
Your answer should be compact. -2.94e+06. What is the difference between the Number of enrolments of both sexes of Oman in 1975 and the Number of enrolments of both sexes of Uruguay in 1978?
Your answer should be compact. -2.77e+05. What is the difference between the Number of enrolments of both sexes in Papua New Guinea in 1975 and the Number of enrolments of both sexes in Tanzania in 1978?
Provide a short and direct response. -2.76e+06. What is the difference between the Number of enrolments of both sexes in Papua New Guinea in 1975 and the Number of enrolments of both sexes in Uruguay in 1978?
Your answer should be very brief. -8.76e+04. What is the difference between the Number of enrolments of both sexes in Tanzania in 1975 and the Number of enrolments of both sexes in Uruguay in 1978?
Give a very brief answer. 1.27e+06. What is the difference between the Number of enrolments of both sexes in Oman in 1976 and the Number of enrolments of both sexes in Papua New Guinea in 1977?
Your answer should be compact. -1.99e+05. What is the difference between the Number of enrolments of both sexes of Oman in 1976 and the Number of enrolments of both sexes of Tanzania in 1977?
Provide a short and direct response. -2.22e+06. What is the difference between the Number of enrolments of both sexes in Oman in 1976 and the Number of enrolments of both sexes in Uruguay in 1977?
Keep it short and to the point. -2.70e+05. What is the difference between the Number of enrolments of both sexes in Papua New Guinea in 1976 and the Number of enrolments of both sexes in Tanzania in 1977?
Provide a succinct answer. -2.02e+06. What is the difference between the Number of enrolments of both sexes of Papua New Guinea in 1976 and the Number of enrolments of both sexes of Uruguay in 1977?
Offer a very short reply. -7.36e+04. What is the difference between the Number of enrolments of both sexes in Tanzania in 1976 and the Number of enrolments of both sexes in Uruguay in 1977?
Your answer should be very brief. 1.63e+06. What is the difference between the Number of enrolments of both sexes of Oman in 1976 and the Number of enrolments of both sexes of Papua New Guinea in 1978?
Provide a succinct answer. -2.09e+05. What is the difference between the Number of enrolments of both sexes in Oman in 1976 and the Number of enrolments of both sexes in Tanzania in 1978?
Offer a very short reply. -2.94e+06. What is the difference between the Number of enrolments of both sexes of Oman in 1976 and the Number of enrolments of both sexes of Uruguay in 1978?
Ensure brevity in your answer.  -2.71e+05. What is the difference between the Number of enrolments of both sexes in Papua New Guinea in 1976 and the Number of enrolments of both sexes in Tanzania in 1978?
Your answer should be compact. -2.74e+06. What is the difference between the Number of enrolments of both sexes of Papua New Guinea in 1976 and the Number of enrolments of both sexes of Uruguay in 1978?
Offer a very short reply. -7.52e+04. What is the difference between the Number of enrolments of both sexes in Tanzania in 1976 and the Number of enrolments of both sexes in Uruguay in 1978?
Ensure brevity in your answer.  1.63e+06. What is the difference between the Number of enrolments of both sexes in Oman in 1977 and the Number of enrolments of both sexes in Papua New Guinea in 1978?
Your response must be concise. -2.01e+05. What is the difference between the Number of enrolments of both sexes in Oman in 1977 and the Number of enrolments of both sexes in Tanzania in 1978?
Offer a very short reply. -2.93e+06. What is the difference between the Number of enrolments of both sexes in Oman in 1977 and the Number of enrolments of both sexes in Uruguay in 1978?
Provide a short and direct response. -2.63e+05. What is the difference between the Number of enrolments of both sexes of Papua New Guinea in 1977 and the Number of enrolments of both sexes of Tanzania in 1978?
Keep it short and to the point. -2.74e+06. What is the difference between the Number of enrolments of both sexes in Papua New Guinea in 1977 and the Number of enrolments of both sexes in Uruguay in 1978?
Provide a short and direct response. -7.19e+04. What is the difference between the Number of enrolments of both sexes in Tanzania in 1977 and the Number of enrolments of both sexes in Uruguay in 1978?
Your response must be concise. 1.95e+06. What is the average Number of enrolments of both sexes of Oman per year?
Provide a succinct answer. 3.94e+04. What is the average Number of enrolments of both sexes of Papua New Guinea per year?
Ensure brevity in your answer.  2.32e+05. What is the average Number of enrolments of both sexes of Tanzania per year?
Your response must be concise. 1.64e+06. What is the average Number of enrolments of both sexes in Uruguay per year?
Keep it short and to the point. 3.37e+05. In the year 1971, what is the difference between the Number of enrolments of both sexes of Oman and Number of enrolments of both sexes of Papua New Guinea?
Provide a succinct answer. -1.92e+05. In the year 1971, what is the difference between the Number of enrolments of both sexes of Oman and Number of enrolments of both sexes of Tanzania?
Offer a terse response. -9.19e+05. In the year 1971, what is the difference between the Number of enrolments of both sexes in Oman and Number of enrolments of both sexes in Uruguay?
Give a very brief answer. -3.56e+05. In the year 1971, what is the difference between the Number of enrolments of both sexes of Papua New Guinea and Number of enrolments of both sexes of Tanzania?
Make the answer very short. -7.26e+05. In the year 1971, what is the difference between the Number of enrolments of both sexes in Papua New Guinea and Number of enrolments of both sexes in Uruguay?
Provide a succinct answer. -1.64e+05. In the year 1971, what is the difference between the Number of enrolments of both sexes of Tanzania and Number of enrolments of both sexes of Uruguay?
Provide a short and direct response. 5.62e+05. In the year 1972, what is the difference between the Number of enrolments of both sexes in Oman and Number of enrolments of both sexes in Papua New Guinea?
Offer a very short reply. -1.89e+05. In the year 1972, what is the difference between the Number of enrolments of both sexes in Oman and Number of enrolments of both sexes in Tanzania?
Your answer should be very brief. -1.00e+06. In the year 1972, what is the difference between the Number of enrolments of both sexes in Oman and Number of enrolments of both sexes in Uruguay?
Offer a very short reply. -3.37e+05. In the year 1972, what is the difference between the Number of enrolments of both sexes of Papua New Guinea and Number of enrolments of both sexes of Tanzania?
Provide a short and direct response. -8.14e+05. In the year 1972, what is the difference between the Number of enrolments of both sexes of Papua New Guinea and Number of enrolments of both sexes of Uruguay?
Provide a short and direct response. -1.48e+05. In the year 1972, what is the difference between the Number of enrolments of both sexes in Tanzania and Number of enrolments of both sexes in Uruguay?
Offer a very short reply. 6.66e+05. In the year 1973, what is the difference between the Number of enrolments of both sexes in Oman and Number of enrolments of both sexes in Papua New Guinea?
Offer a terse response. -1.94e+05. In the year 1973, what is the difference between the Number of enrolments of both sexes of Oman and Number of enrolments of both sexes of Tanzania?
Provide a short and direct response. -1.10e+06. In the year 1973, what is the difference between the Number of enrolments of both sexes in Oman and Number of enrolments of both sexes in Uruguay?
Make the answer very short. -3.29e+05. In the year 1973, what is the difference between the Number of enrolments of both sexes of Papua New Guinea and Number of enrolments of both sexes of Tanzania?
Your response must be concise. -9.08e+05. In the year 1973, what is the difference between the Number of enrolments of both sexes of Papua New Guinea and Number of enrolments of both sexes of Uruguay?
Offer a very short reply. -1.35e+05. In the year 1973, what is the difference between the Number of enrolments of both sexes of Tanzania and Number of enrolments of both sexes of Uruguay?
Provide a succinct answer. 7.73e+05. In the year 1974, what is the difference between the Number of enrolments of both sexes in Oman and Number of enrolments of both sexes in Papua New Guinea?
Offer a terse response. -1.94e+05. In the year 1974, what is the difference between the Number of enrolments of both sexes of Oman and Number of enrolments of both sexes of Tanzania?
Provide a succinct answer. -1.22e+06. In the year 1974, what is the difference between the Number of enrolments of both sexes in Oman and Number of enrolments of both sexes in Uruguay?
Provide a short and direct response. -2.96e+05. In the year 1974, what is the difference between the Number of enrolments of both sexes in Papua New Guinea and Number of enrolments of both sexes in Tanzania?
Provide a succinct answer. -1.03e+06. In the year 1974, what is the difference between the Number of enrolments of both sexes of Papua New Guinea and Number of enrolments of both sexes of Uruguay?
Offer a very short reply. -1.02e+05. In the year 1974, what is the difference between the Number of enrolments of both sexes in Tanzania and Number of enrolments of both sexes in Uruguay?
Offer a terse response. 9.29e+05. In the year 1975, what is the difference between the Number of enrolments of both sexes in Oman and Number of enrolments of both sexes in Papua New Guinea?
Your answer should be compact. -1.90e+05. In the year 1975, what is the difference between the Number of enrolments of both sexes in Oman and Number of enrolments of both sexes in Tanzania?
Give a very brief answer. -1.54e+06. In the year 1975, what is the difference between the Number of enrolments of both sexes of Oman and Number of enrolments of both sexes of Uruguay?
Offer a very short reply. -2.74e+05. In the year 1975, what is the difference between the Number of enrolments of both sexes in Papua New Guinea and Number of enrolments of both sexes in Tanzania?
Provide a short and direct response. -1.35e+06. In the year 1975, what is the difference between the Number of enrolments of both sexes in Papua New Guinea and Number of enrolments of both sexes in Uruguay?
Provide a short and direct response. -8.43e+04. In the year 1975, what is the difference between the Number of enrolments of both sexes of Tanzania and Number of enrolments of both sexes of Uruguay?
Give a very brief answer. 1.27e+06. In the year 1976, what is the difference between the Number of enrolments of both sexes of Oman and Number of enrolments of both sexes of Papua New Guinea?
Provide a succinct answer. -1.96e+05. In the year 1976, what is the difference between the Number of enrolments of both sexes of Oman and Number of enrolments of both sexes of Tanzania?
Provide a short and direct response. -1.90e+06. In the year 1976, what is the difference between the Number of enrolments of both sexes in Oman and Number of enrolments of both sexes in Uruguay?
Provide a short and direct response. -2.68e+05. In the year 1976, what is the difference between the Number of enrolments of both sexes in Papua New Guinea and Number of enrolments of both sexes in Tanzania?
Provide a succinct answer. -1.70e+06. In the year 1976, what is the difference between the Number of enrolments of both sexes in Papua New Guinea and Number of enrolments of both sexes in Uruguay?
Your answer should be very brief. -7.22e+04. In the year 1976, what is the difference between the Number of enrolments of both sexes in Tanzania and Number of enrolments of both sexes in Uruguay?
Offer a terse response. 1.63e+06. In the year 1977, what is the difference between the Number of enrolments of both sexes of Oman and Number of enrolments of both sexes of Papua New Guinea?
Provide a short and direct response. -1.91e+05. In the year 1977, what is the difference between the Number of enrolments of both sexes of Oman and Number of enrolments of both sexes of Tanzania?
Provide a short and direct response. -2.21e+06. In the year 1977, what is the difference between the Number of enrolments of both sexes of Oman and Number of enrolments of both sexes of Uruguay?
Offer a very short reply. -2.62e+05. In the year 1977, what is the difference between the Number of enrolments of both sexes in Papua New Guinea and Number of enrolments of both sexes in Tanzania?
Ensure brevity in your answer.  -2.02e+06. In the year 1977, what is the difference between the Number of enrolments of both sexes of Papua New Guinea and Number of enrolments of both sexes of Uruguay?
Your response must be concise. -7.04e+04. In the year 1977, what is the difference between the Number of enrolments of both sexes of Tanzania and Number of enrolments of both sexes of Uruguay?
Provide a succinct answer. 1.95e+06. In the year 1978, what is the difference between the Number of enrolments of both sexes of Oman and Number of enrolments of both sexes of Papua New Guinea?
Provide a succinct answer. -1.92e+05. In the year 1978, what is the difference between the Number of enrolments of both sexes in Oman and Number of enrolments of both sexes in Tanzania?
Offer a very short reply. -2.92e+06. In the year 1978, what is the difference between the Number of enrolments of both sexes of Oman and Number of enrolments of both sexes of Uruguay?
Offer a terse response. -2.55e+05. In the year 1978, what is the difference between the Number of enrolments of both sexes in Papua New Guinea and Number of enrolments of both sexes in Tanzania?
Provide a succinct answer. -2.73e+06. In the year 1978, what is the difference between the Number of enrolments of both sexes of Papua New Guinea and Number of enrolments of both sexes of Uruguay?
Give a very brief answer. -6.27e+04. In the year 1978, what is the difference between the Number of enrolments of both sexes of Tanzania and Number of enrolments of both sexes of Uruguay?
Give a very brief answer. 2.67e+06. What is the ratio of the Number of enrolments of both sexes of Oman in 1971 to that in 1972?
Offer a terse response. 0.23. What is the ratio of the Number of enrolments of both sexes of Papua New Guinea in 1971 to that in 1972?
Keep it short and to the point. 0.96. What is the ratio of the Number of enrolments of both sexes of Tanzania in 1971 to that in 1972?
Your answer should be compact. 0.91. What is the ratio of the Number of enrolments of both sexes in Uruguay in 1971 to that in 1972?
Keep it short and to the point. 1.02. What is the ratio of the Number of enrolments of both sexes of Oman in 1971 to that in 1973?
Give a very brief answer. 0.14. What is the ratio of the Number of enrolments of both sexes in Papua New Guinea in 1971 to that in 1973?
Provide a short and direct response. 0.9. What is the ratio of the Number of enrolments of both sexes of Tanzania in 1971 to that in 1973?
Keep it short and to the point. 0.82. What is the ratio of the Number of enrolments of both sexes of Uruguay in 1971 to that in 1973?
Provide a short and direct response. 1.02. What is the ratio of the Number of enrolments of both sexes in Oman in 1971 to that in 1974?
Keep it short and to the point. 0.1. What is the ratio of the Number of enrolments of both sexes of Papua New Guinea in 1971 to that in 1974?
Keep it short and to the point. 0.85. What is the ratio of the Number of enrolments of both sexes in Tanzania in 1971 to that in 1974?
Provide a succinct answer. 0.73. What is the ratio of the Number of enrolments of both sexes in Uruguay in 1971 to that in 1974?
Offer a terse response. 1.09. What is the ratio of the Number of enrolments of both sexes of Oman in 1971 to that in 1975?
Keep it short and to the point. 0.07. What is the ratio of the Number of enrolments of both sexes of Papua New Guinea in 1971 to that in 1975?
Your answer should be compact. 0.82. What is the ratio of the Number of enrolments of both sexes in Tanzania in 1971 to that in 1975?
Make the answer very short. 0.58. What is the ratio of the Number of enrolments of both sexes of Uruguay in 1971 to that in 1975?
Offer a terse response. 1.12. What is the ratio of the Number of enrolments of both sexes in Oman in 1971 to that in 1976?
Give a very brief answer. 0.06. What is the ratio of the Number of enrolments of both sexes in Papua New Guinea in 1971 to that in 1976?
Provide a succinct answer. 0.78. What is the ratio of the Number of enrolments of both sexes in Tanzania in 1971 to that in 1976?
Your response must be concise. 0.47. What is the ratio of the Number of enrolments of both sexes of Uruguay in 1971 to that in 1976?
Your response must be concise. 1.11. What is the ratio of the Number of enrolments of both sexes of Oman in 1971 to that in 1977?
Ensure brevity in your answer.  0.06. What is the ratio of the Number of enrolments of both sexes in Papua New Guinea in 1971 to that in 1977?
Offer a terse response. 0.77. What is the ratio of the Number of enrolments of both sexes in Tanzania in 1971 to that in 1977?
Offer a terse response. 0.41. What is the ratio of the Number of enrolments of both sexes in Uruguay in 1971 to that in 1977?
Offer a terse response. 1.11. What is the ratio of the Number of enrolments of both sexes of Oman in 1971 to that in 1978?
Make the answer very short. 0.05. What is the ratio of the Number of enrolments of both sexes in Papua New Guinea in 1971 to that in 1978?
Your answer should be compact. 0.74. What is the ratio of the Number of enrolments of both sexes in Tanzania in 1971 to that in 1978?
Offer a very short reply. 0.31. What is the ratio of the Number of enrolments of both sexes in Uruguay in 1971 to that in 1978?
Ensure brevity in your answer.  1.1. What is the ratio of the Number of enrolments of both sexes in Oman in 1972 to that in 1973?
Ensure brevity in your answer.  0.63. What is the ratio of the Number of enrolments of both sexes in Papua New Guinea in 1972 to that in 1973?
Offer a very short reply. 0.94. What is the ratio of the Number of enrolments of both sexes in Tanzania in 1972 to that in 1973?
Ensure brevity in your answer.  0.9. What is the ratio of the Number of enrolments of both sexes in Uruguay in 1972 to that in 1973?
Ensure brevity in your answer.  1. What is the ratio of the Number of enrolments of both sexes in Oman in 1972 to that in 1974?
Your answer should be very brief. 0.43. What is the ratio of the Number of enrolments of both sexes in Papua New Guinea in 1972 to that in 1974?
Make the answer very short. 0.89. What is the ratio of the Number of enrolments of both sexes of Tanzania in 1972 to that in 1974?
Give a very brief answer. 0.81. What is the ratio of the Number of enrolments of both sexes in Uruguay in 1972 to that in 1974?
Offer a very short reply. 1.06. What is the ratio of the Number of enrolments of both sexes in Oman in 1972 to that in 1975?
Make the answer very short. 0.32. What is the ratio of the Number of enrolments of both sexes of Tanzania in 1972 to that in 1975?
Your answer should be compact. 0.64. What is the ratio of the Number of enrolments of both sexes of Uruguay in 1972 to that in 1975?
Provide a short and direct response. 1.09. What is the ratio of the Number of enrolments of both sexes in Oman in 1972 to that in 1976?
Provide a succinct answer. 0.28. What is the ratio of the Number of enrolments of both sexes of Papua New Guinea in 1972 to that in 1976?
Your answer should be compact. 0.81. What is the ratio of the Number of enrolments of both sexes in Tanzania in 1972 to that in 1976?
Offer a terse response. 0.52. What is the ratio of the Number of enrolments of both sexes in Uruguay in 1972 to that in 1976?
Keep it short and to the point. 1.09. What is the ratio of the Number of enrolments of both sexes in Oman in 1972 to that in 1977?
Ensure brevity in your answer.  0.24. What is the ratio of the Number of enrolments of both sexes in Papua New Guinea in 1972 to that in 1977?
Your answer should be compact. 0.8. What is the ratio of the Number of enrolments of both sexes in Tanzania in 1972 to that in 1977?
Make the answer very short. 0.45. What is the ratio of the Number of enrolments of both sexes of Uruguay in 1972 to that in 1977?
Provide a succinct answer. 1.09. What is the ratio of the Number of enrolments of both sexes of Oman in 1972 to that in 1978?
Your answer should be very brief. 0.22. What is the ratio of the Number of enrolments of both sexes of Papua New Guinea in 1972 to that in 1978?
Offer a terse response. 0.78. What is the ratio of the Number of enrolments of both sexes of Tanzania in 1972 to that in 1978?
Your answer should be very brief. 0.34. What is the ratio of the Number of enrolments of both sexes of Uruguay in 1972 to that in 1978?
Provide a short and direct response. 1.08. What is the ratio of the Number of enrolments of both sexes of Oman in 1973 to that in 1974?
Your answer should be compact. 0.69. What is the ratio of the Number of enrolments of both sexes in Papua New Guinea in 1973 to that in 1974?
Make the answer very short. 0.95. What is the ratio of the Number of enrolments of both sexes of Tanzania in 1973 to that in 1974?
Offer a terse response. 0.89. What is the ratio of the Number of enrolments of both sexes in Uruguay in 1973 to that in 1974?
Offer a very short reply. 1.07. What is the ratio of the Number of enrolments of both sexes in Oman in 1973 to that in 1975?
Provide a short and direct response. 0.5. What is the ratio of the Number of enrolments of both sexes of Papua New Guinea in 1973 to that in 1975?
Ensure brevity in your answer.  0.92. What is the ratio of the Number of enrolments of both sexes in Tanzania in 1973 to that in 1975?
Give a very brief answer. 0.71. What is the ratio of the Number of enrolments of both sexes in Uruguay in 1973 to that in 1975?
Your answer should be compact. 1.1. What is the ratio of the Number of enrolments of both sexes of Oman in 1973 to that in 1976?
Keep it short and to the point. 0.45. What is the ratio of the Number of enrolments of both sexes in Papua New Guinea in 1973 to that in 1976?
Your answer should be compact. 0.87. What is the ratio of the Number of enrolments of both sexes of Tanzania in 1973 to that in 1976?
Ensure brevity in your answer.  0.58. What is the ratio of the Number of enrolments of both sexes in Uruguay in 1973 to that in 1976?
Keep it short and to the point. 1.1. What is the ratio of the Number of enrolments of both sexes in Oman in 1973 to that in 1977?
Make the answer very short. 0.39. What is the ratio of the Number of enrolments of both sexes of Papua New Guinea in 1973 to that in 1977?
Provide a short and direct response. 0.86. What is the ratio of the Number of enrolments of both sexes of Tanzania in 1973 to that in 1977?
Ensure brevity in your answer.  0.5. What is the ratio of the Number of enrolments of both sexes in Uruguay in 1973 to that in 1977?
Your answer should be compact. 1.09. What is the ratio of the Number of enrolments of both sexes of Oman in 1973 to that in 1978?
Offer a very short reply. 0.34. What is the ratio of the Number of enrolments of both sexes in Papua New Guinea in 1973 to that in 1978?
Give a very brief answer. 0.83. What is the ratio of the Number of enrolments of both sexes of Tanzania in 1973 to that in 1978?
Provide a short and direct response. 0.38. What is the ratio of the Number of enrolments of both sexes of Uruguay in 1973 to that in 1978?
Keep it short and to the point. 1.09. What is the ratio of the Number of enrolments of both sexes in Oman in 1974 to that in 1975?
Offer a terse response. 0.73. What is the ratio of the Number of enrolments of both sexes in Papua New Guinea in 1974 to that in 1975?
Give a very brief answer. 0.96. What is the ratio of the Number of enrolments of both sexes of Tanzania in 1974 to that in 1975?
Ensure brevity in your answer.  0.79. What is the ratio of the Number of enrolments of both sexes in Uruguay in 1974 to that in 1975?
Ensure brevity in your answer.  1.03. What is the ratio of the Number of enrolments of both sexes in Oman in 1974 to that in 1976?
Give a very brief answer. 0.65. What is the ratio of the Number of enrolments of both sexes in Papua New Guinea in 1974 to that in 1976?
Provide a succinct answer. 0.92. What is the ratio of the Number of enrolments of both sexes in Tanzania in 1974 to that in 1976?
Keep it short and to the point. 0.65. What is the ratio of the Number of enrolments of both sexes of Uruguay in 1974 to that in 1976?
Provide a succinct answer. 1.03. What is the ratio of the Number of enrolments of both sexes in Oman in 1974 to that in 1977?
Offer a very short reply. 0.56. What is the ratio of the Number of enrolments of both sexes in Papua New Guinea in 1974 to that in 1977?
Provide a succinct answer. 0.9. What is the ratio of the Number of enrolments of both sexes in Tanzania in 1974 to that in 1977?
Ensure brevity in your answer.  0.55. What is the ratio of the Number of enrolments of both sexes in Uruguay in 1974 to that in 1977?
Make the answer very short. 1.02. What is the ratio of the Number of enrolments of both sexes of Oman in 1974 to that in 1978?
Ensure brevity in your answer.  0.5. What is the ratio of the Number of enrolments of both sexes in Papua New Guinea in 1974 to that in 1978?
Ensure brevity in your answer.  0.87. What is the ratio of the Number of enrolments of both sexes of Tanzania in 1974 to that in 1978?
Your answer should be compact. 0.42. What is the ratio of the Number of enrolments of both sexes in Uruguay in 1974 to that in 1978?
Ensure brevity in your answer.  1.02. What is the ratio of the Number of enrolments of both sexes of Oman in 1975 to that in 1976?
Offer a very short reply. 0.89. What is the ratio of the Number of enrolments of both sexes in Papua New Guinea in 1975 to that in 1976?
Keep it short and to the point. 0.95. What is the ratio of the Number of enrolments of both sexes in Tanzania in 1975 to that in 1976?
Provide a succinct answer. 0.82. What is the ratio of the Number of enrolments of both sexes of Uruguay in 1975 to that in 1976?
Give a very brief answer. 1. What is the ratio of the Number of enrolments of both sexes in Oman in 1975 to that in 1977?
Provide a short and direct response. 0.78. What is the ratio of the Number of enrolments of both sexes in Papua New Guinea in 1975 to that in 1977?
Offer a terse response. 0.94. What is the ratio of the Number of enrolments of both sexes in Tanzania in 1975 to that in 1977?
Your response must be concise. 0.7. What is the ratio of the Number of enrolments of both sexes of Uruguay in 1975 to that in 1977?
Offer a terse response. 0.99. What is the ratio of the Number of enrolments of both sexes in Oman in 1975 to that in 1978?
Provide a succinct answer. 0.69. What is the ratio of the Number of enrolments of both sexes of Papua New Guinea in 1975 to that in 1978?
Provide a short and direct response. 0.91. What is the ratio of the Number of enrolments of both sexes of Tanzania in 1975 to that in 1978?
Make the answer very short. 0.53. What is the ratio of the Number of enrolments of both sexes in Oman in 1976 to that in 1977?
Make the answer very short. 0.87. What is the ratio of the Number of enrolments of both sexes in Papua New Guinea in 1976 to that in 1977?
Give a very brief answer. 0.99. What is the ratio of the Number of enrolments of both sexes in Tanzania in 1976 to that in 1977?
Your response must be concise. 0.86. What is the ratio of the Number of enrolments of both sexes of Oman in 1976 to that in 1978?
Ensure brevity in your answer.  0.77. What is the ratio of the Number of enrolments of both sexes of Papua New Guinea in 1976 to that in 1978?
Keep it short and to the point. 0.95. What is the ratio of the Number of enrolments of both sexes in Tanzania in 1976 to that in 1978?
Your answer should be very brief. 0.65. What is the ratio of the Number of enrolments of both sexes of Uruguay in 1976 to that in 1978?
Make the answer very short. 0.99. What is the ratio of the Number of enrolments of both sexes of Oman in 1977 to that in 1978?
Your answer should be compact. 0.89. What is the ratio of the Number of enrolments of both sexes in Papua New Guinea in 1977 to that in 1978?
Your response must be concise. 0.97. What is the ratio of the Number of enrolments of both sexes of Tanzania in 1977 to that in 1978?
Make the answer very short. 0.76. What is the difference between the highest and the second highest Number of enrolments of both sexes of Oman?
Offer a very short reply. 8121. What is the difference between the highest and the second highest Number of enrolments of both sexes in Papua New Guinea?
Your answer should be very brief. 9184. What is the difference between the highest and the second highest Number of enrolments of both sexes of Tanzania?
Provide a short and direct response. 7.19e+05. What is the difference between the highest and the second highest Number of enrolments of both sexes of Uruguay?
Your response must be concise. 6275. What is the difference between the highest and the lowest Number of enrolments of both sexes of Oman?
Give a very brief answer. 6.73e+04. What is the difference between the highest and the lowest Number of enrolments of both sexes of Papua New Guinea?
Provide a succinct answer. 6.73e+04. What is the difference between the highest and the lowest Number of enrolments of both sexes of Tanzania?
Provide a succinct answer. 2.07e+06. What is the difference between the highest and the lowest Number of enrolments of both sexes of Uruguay?
Provide a short and direct response. 3.73e+04. 